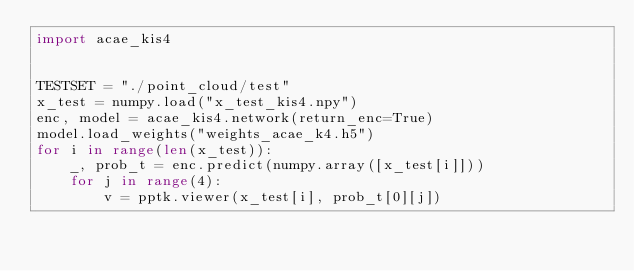Convert code to text. <code><loc_0><loc_0><loc_500><loc_500><_Python_>import acae_kis4


TESTSET = "./point_cloud/test"
x_test = numpy.load("x_test_kis4.npy")
enc, model = acae_kis4.network(return_enc=True)
model.load_weights("weights_acae_k4.h5")
for i in range(len(x_test)):
    _, prob_t = enc.predict(numpy.array([x_test[i]]))
    for j in range(4):
        v = pptk.viewer(x_test[i], prob_t[0][j])</code> 